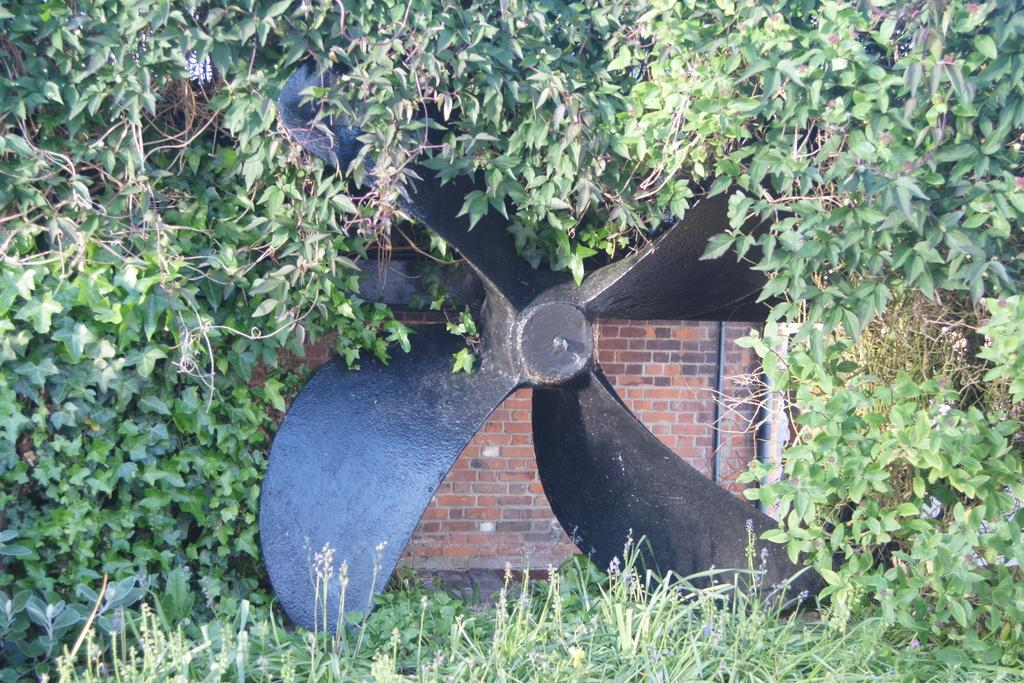What type of structure is shown rotating in the image? There is a rotating brick wall in the image. What type of vegetation can be seen in the image? Grass is visible in the image. What else can be found in the image besides the rotating brick wall and grass? Leaves are present in the image. Can you see a river flowing through the image? No, there is no river present in the image. 